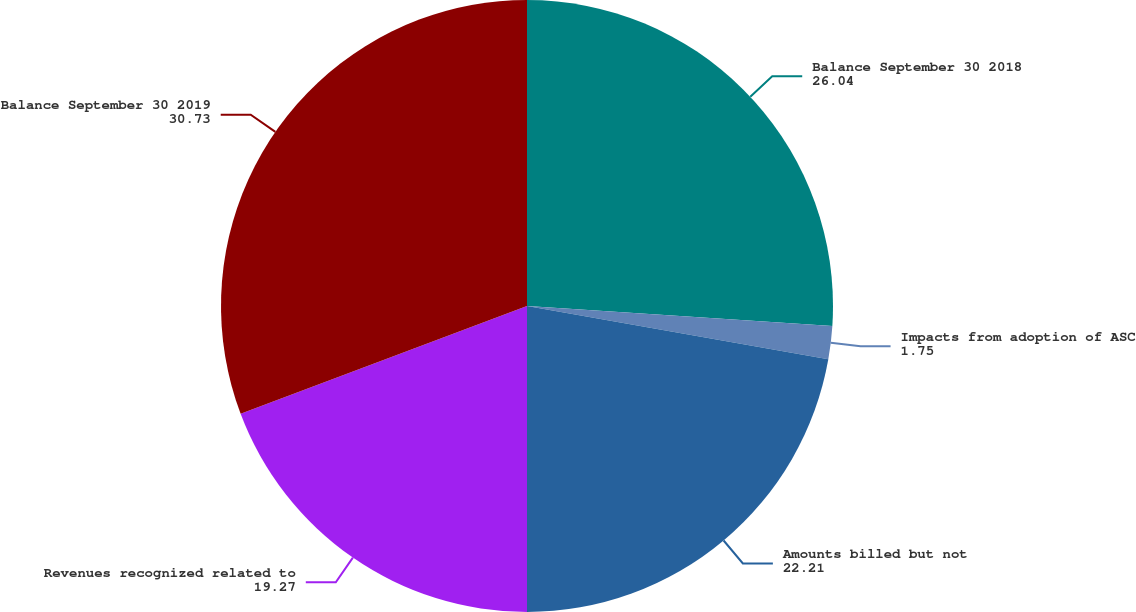Convert chart. <chart><loc_0><loc_0><loc_500><loc_500><pie_chart><fcel>Balance September 30 2018<fcel>Impacts from adoption of ASC<fcel>Amounts billed but not<fcel>Revenues recognized related to<fcel>Balance September 30 2019<nl><fcel>26.04%<fcel>1.75%<fcel>22.21%<fcel>19.27%<fcel>30.73%<nl></chart> 